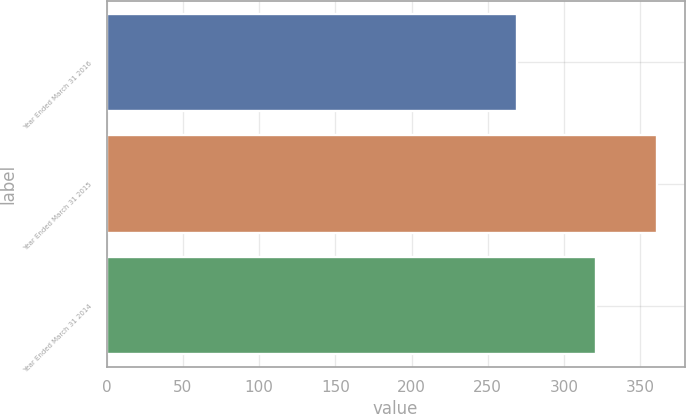Convert chart. <chart><loc_0><loc_0><loc_500><loc_500><bar_chart><fcel>Year Ended March 31 2016<fcel>Year Ended March 31 2015<fcel>Year Ended March 31 2014<nl><fcel>269<fcel>361<fcel>321<nl></chart> 